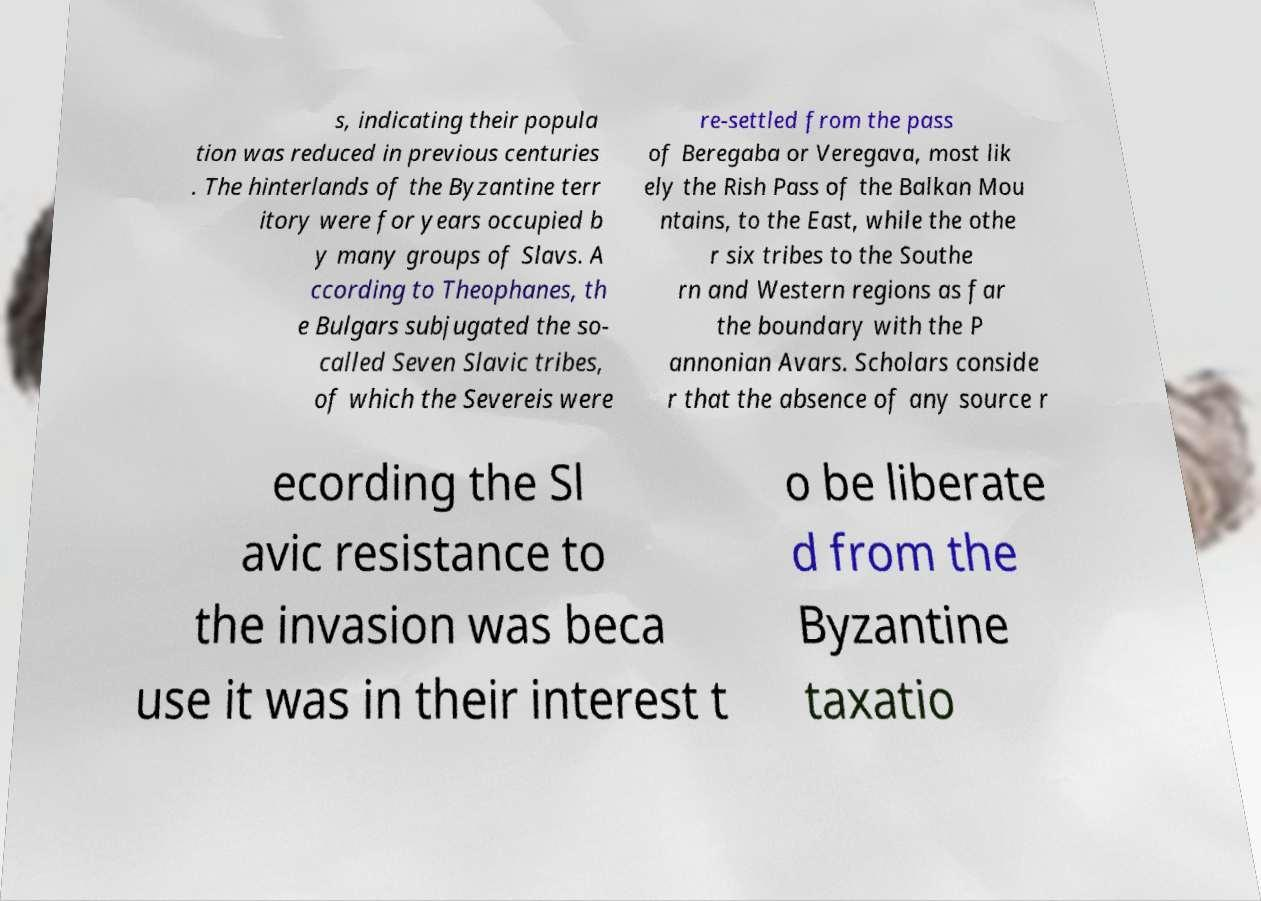What messages or text are displayed in this image? I need them in a readable, typed format. s, indicating their popula tion was reduced in previous centuries . The hinterlands of the Byzantine terr itory were for years occupied b y many groups of Slavs. A ccording to Theophanes, th e Bulgars subjugated the so- called Seven Slavic tribes, of which the Severeis were re-settled from the pass of Beregaba or Veregava, most lik ely the Rish Pass of the Balkan Mou ntains, to the East, while the othe r six tribes to the Southe rn and Western regions as far the boundary with the P annonian Avars. Scholars conside r that the absence of any source r ecording the Sl avic resistance to the invasion was beca use it was in their interest t o be liberate d from the Byzantine taxatio 